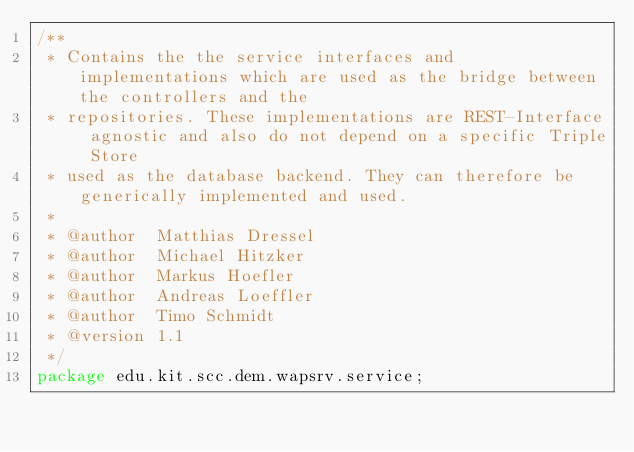<code> <loc_0><loc_0><loc_500><loc_500><_Java_>/**
 * Contains the the service interfaces and implementations which are used as the bridge between the controllers and the
 * repositories. These implementations are REST-Interface agnostic and also do not depend on a specific Triple Store
 * used as the database backend. They can therefore be generically implemented and used.
 * 
 * @author  Matthias Dressel
 * @author  Michael Hitzker
 * @author  Markus Hoefler
 * @author  Andreas Loeffler
 * @author  Timo Schmidt
 * @version 1.1
 */
package edu.kit.scc.dem.wapsrv.service;
</code> 